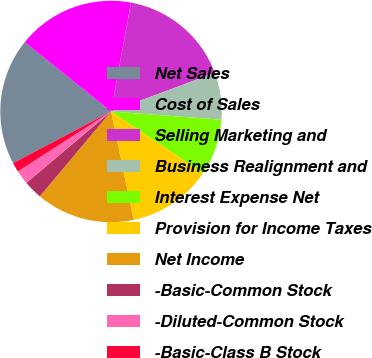<chart> <loc_0><loc_0><loc_500><loc_500><pie_chart><fcel>Net Sales<fcel>Cost of Sales<fcel>Selling Marketing and<fcel>Business Realignment and<fcel>Interest Expense Net<fcel>Provision for Income Taxes<fcel>Net Income<fcel>-Basic-Common Stock<fcel>-Diluted-Common Stock<fcel>-Basic-Class B Stock<nl><fcel>18.49%<fcel>17.12%<fcel>16.44%<fcel>6.85%<fcel>8.22%<fcel>12.33%<fcel>14.38%<fcel>2.74%<fcel>2.05%<fcel>1.37%<nl></chart> 